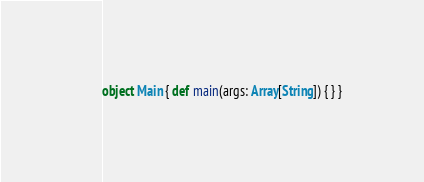<code> <loc_0><loc_0><loc_500><loc_500><_Scala_>object Main { def main(args: Array[String]) { } }
</code> 